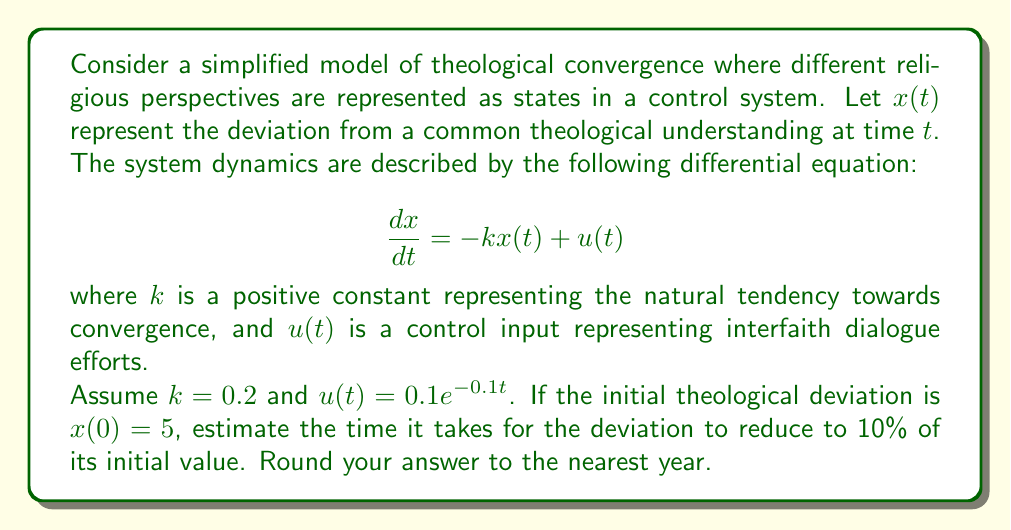Could you help me with this problem? To solve this problem, we'll use principles from control theory:

1) First, we need to solve the differential equation. The general solution is:

   $$x(t) = Ce^{-kt} + x_p(t)$$

   where $C$ is a constant and $x_p(t)$ is the particular solution.

2) For the particular solution, we can guess $x_p(t) = Ae^{-0.1t}$. Substituting this into the original equation:

   $$-0.1Ae^{-0.1t} = -0.2Ae^{-0.1t} + 0.1e^{-0.1t}$$

   Solving for $A$:
   
   $$A = 1$$

3) Now our general solution is:

   $$x(t) = Ce^{-0.2t} + e^{-0.1t}$$

4) Using the initial condition $x(0) = 5$:

   $$5 = C + 1$$
   $$C = 4$$

5) So our final solution is:

   $$x(t) = 4e^{-0.2t} + e^{-0.1t}$$

6) We want to find $t$ when $x(t) = 0.5$ (10% of the initial value):

   $$0.5 = 4e^{-0.2t} + e^{-0.1t}$$

7) This equation can't be solved analytically. We need to use numerical methods or graphing to find $t$. Using a numerical solver, we find:

   $$t \approx 11.5 \text{ years}$$

8) Rounding to the nearest year gives us 12 years.
Answer: 12 years 